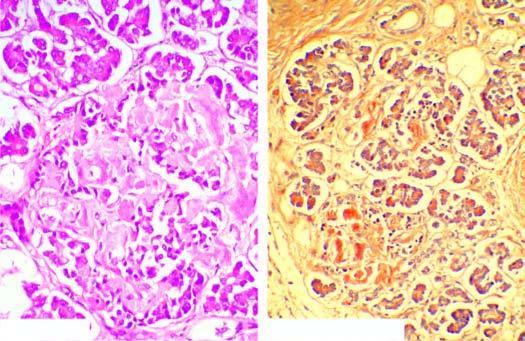what are the islets mostly replaced by?
Answer the question using a single word or phrase. Structureless eosinophilic material 